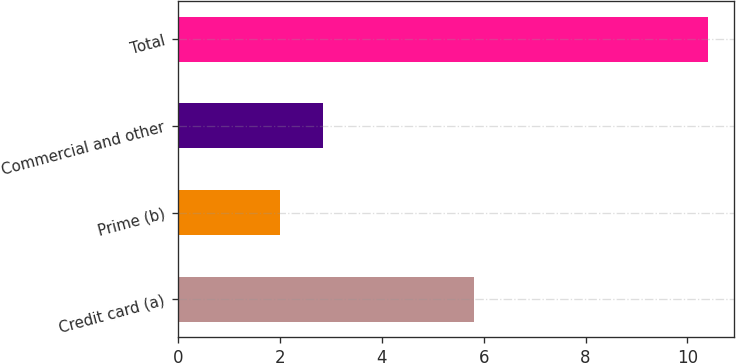Convert chart to OTSL. <chart><loc_0><loc_0><loc_500><loc_500><bar_chart><fcel>Credit card (a)<fcel>Prime (b)<fcel>Commercial and other<fcel>Total<nl><fcel>5.8<fcel>2<fcel>2.84<fcel>10.4<nl></chart> 